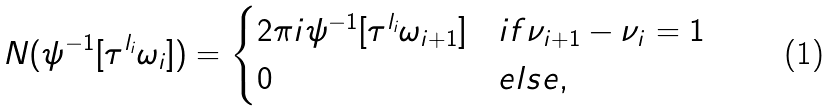Convert formula to latex. <formula><loc_0><loc_0><loc_500><loc_500>N ( \psi ^ { - 1 } [ \tau ^ { l _ { i } } \omega _ { i } ] ) = \begin{cases} 2 \pi i \psi ^ { - 1 } [ \tau ^ { l _ { i } } \omega _ { i + 1 } ] & i f \nu _ { i + 1 } - \nu _ { i } = 1 \\ 0 & e l s e , \end{cases}</formula> 